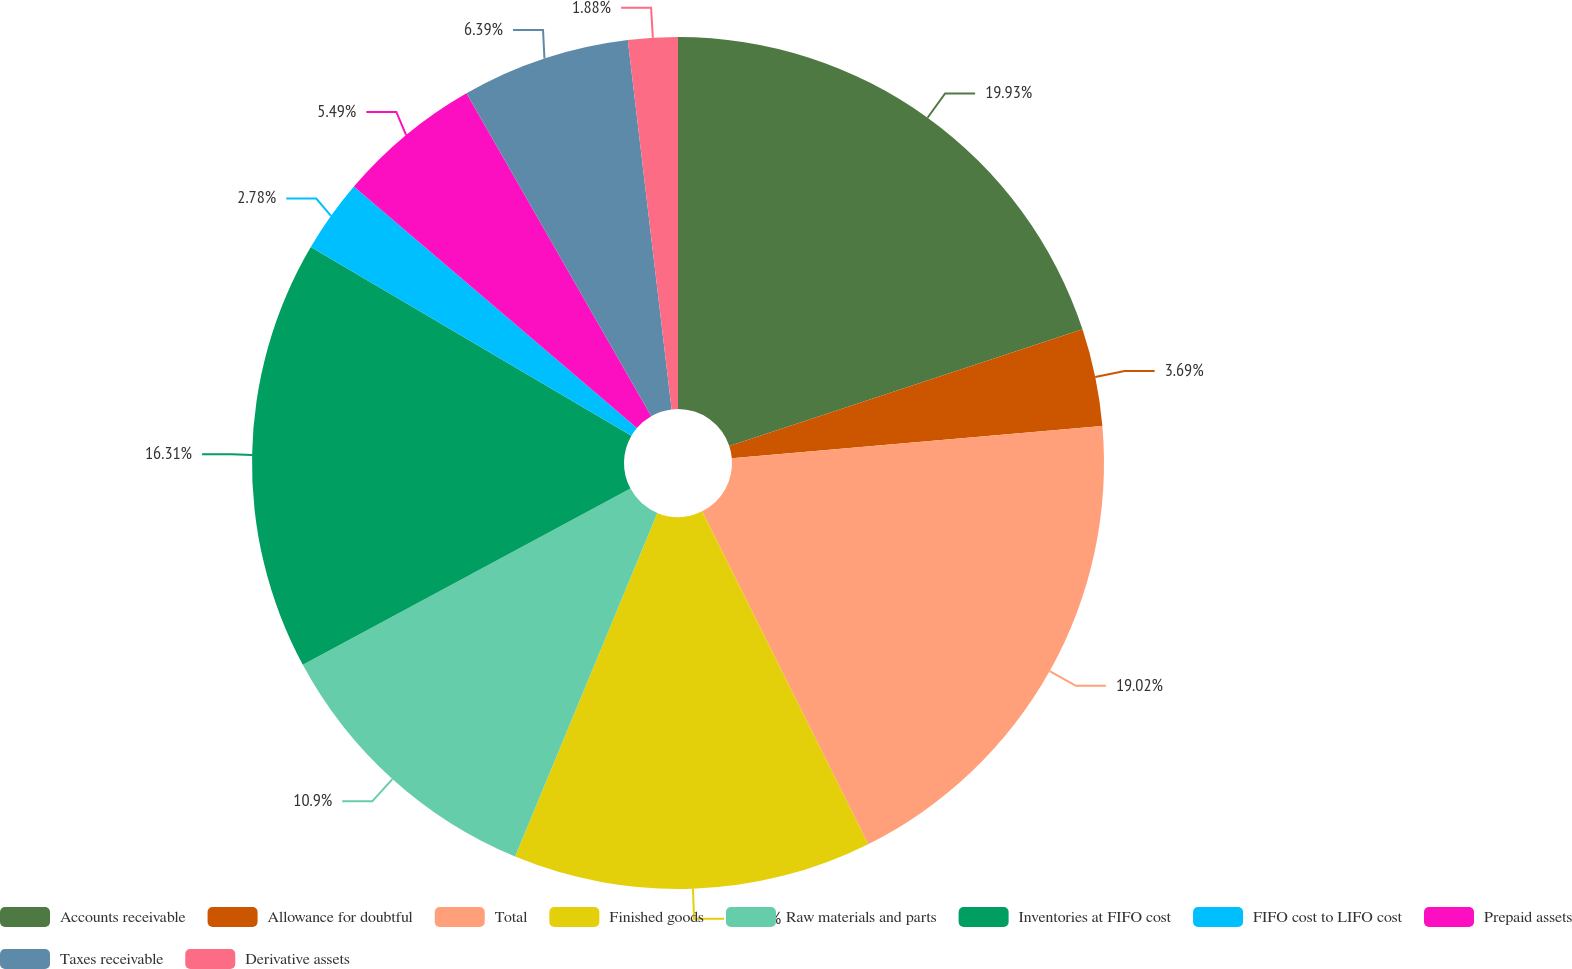<chart> <loc_0><loc_0><loc_500><loc_500><pie_chart><fcel>Accounts receivable<fcel>Allowance for doubtful<fcel>Total<fcel>Finished goods<fcel>Raw materials and parts<fcel>Inventories at FIFO cost<fcel>FIFO cost to LIFO cost<fcel>Prepaid assets<fcel>Taxes receivable<fcel>Derivative assets<nl><fcel>19.92%<fcel>3.69%<fcel>19.02%<fcel>13.61%<fcel>10.9%<fcel>16.31%<fcel>2.78%<fcel>5.49%<fcel>6.39%<fcel>1.88%<nl></chart> 